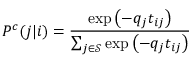Convert formula to latex. <formula><loc_0><loc_0><loc_500><loc_500>P ^ { c } ( j | i ) = \frac { \exp { \left ( - q _ { j } t _ { i j } \right ) } } { \sum _ { j \in \mathcal { S } } \exp { \left ( - q _ { j } t _ { i j } \right ) } }</formula> 